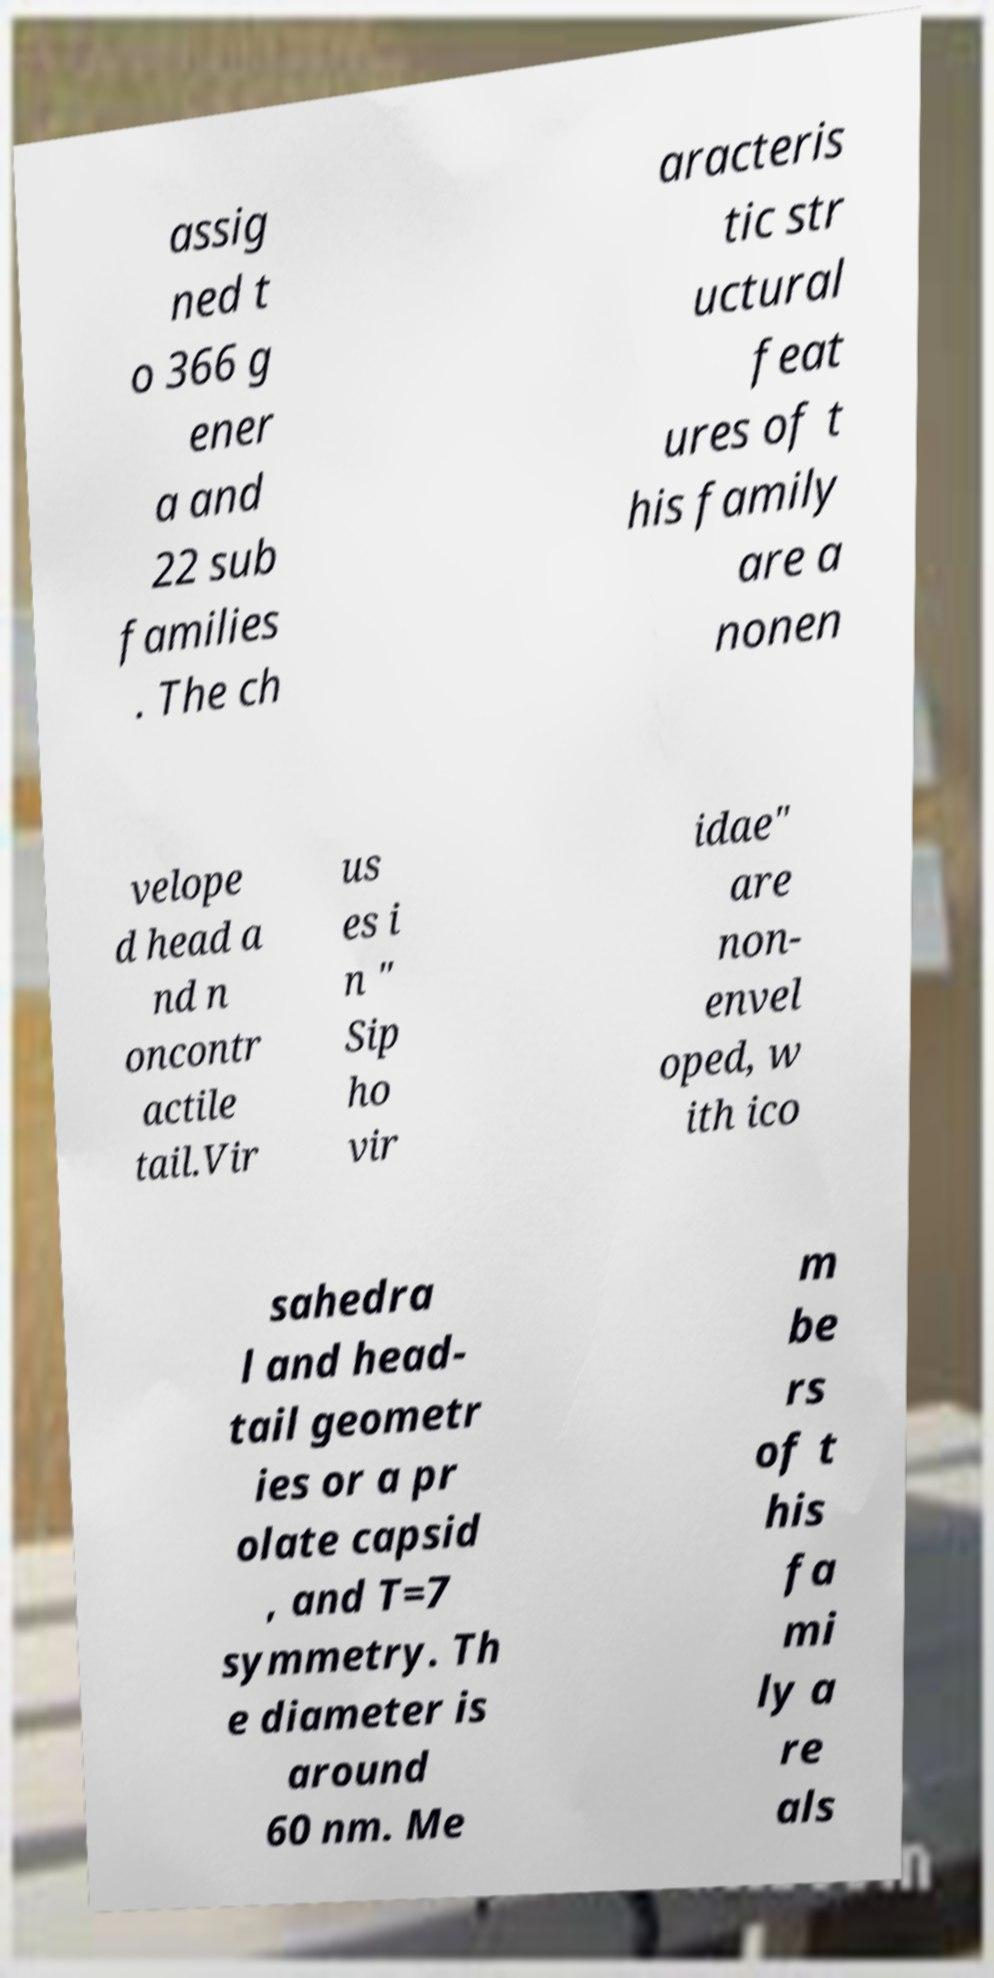Can you accurately transcribe the text from the provided image for me? assig ned t o 366 g ener a and 22 sub families . The ch aracteris tic str uctural feat ures of t his family are a nonen velope d head a nd n oncontr actile tail.Vir us es i n " Sip ho vir idae" are non- envel oped, w ith ico sahedra l and head- tail geometr ies or a pr olate capsid , and T=7 symmetry. Th e diameter is around 60 nm. Me m be rs of t his fa mi ly a re als 